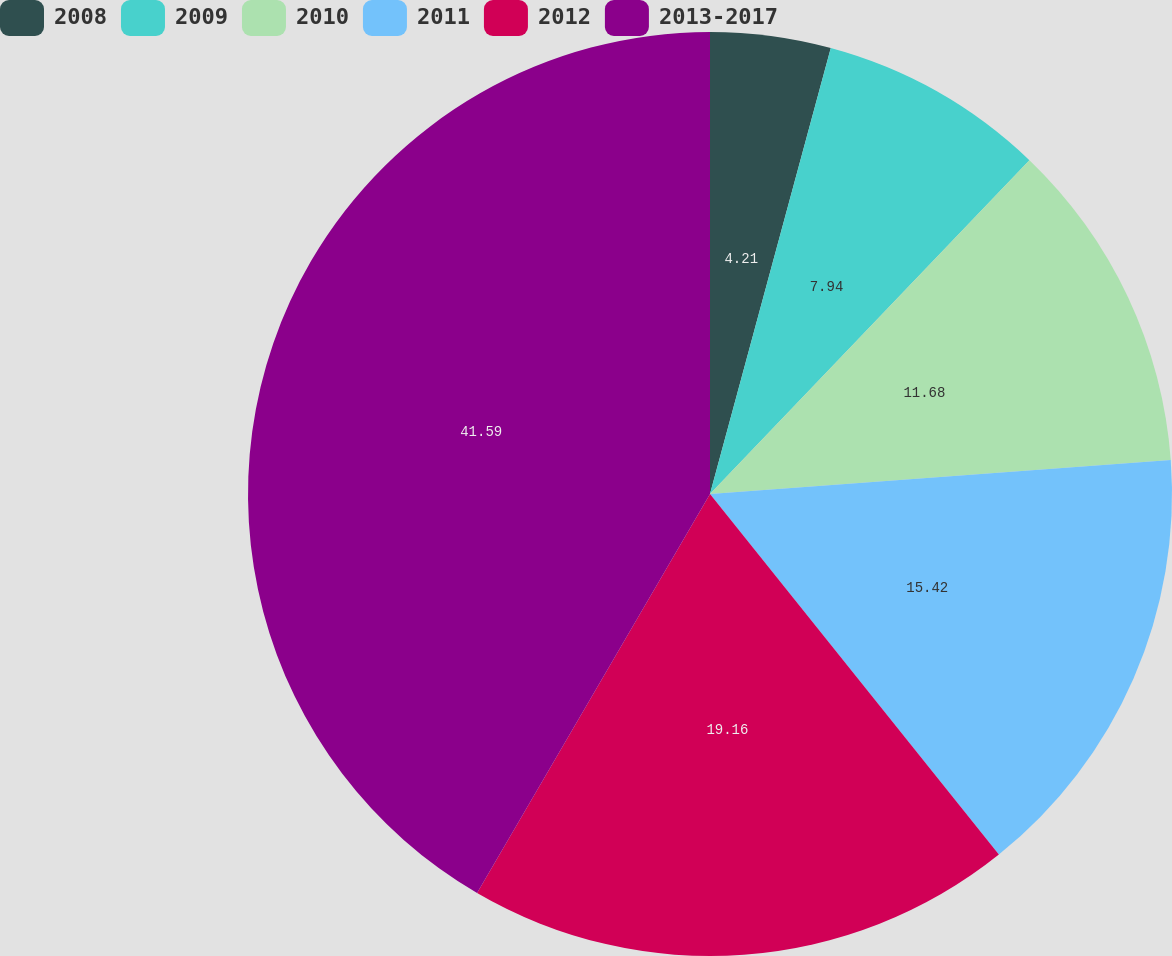Convert chart. <chart><loc_0><loc_0><loc_500><loc_500><pie_chart><fcel>2008<fcel>2009<fcel>2010<fcel>2011<fcel>2012<fcel>2013-2017<nl><fcel>4.21%<fcel>7.94%<fcel>11.68%<fcel>15.42%<fcel>19.16%<fcel>41.59%<nl></chart> 